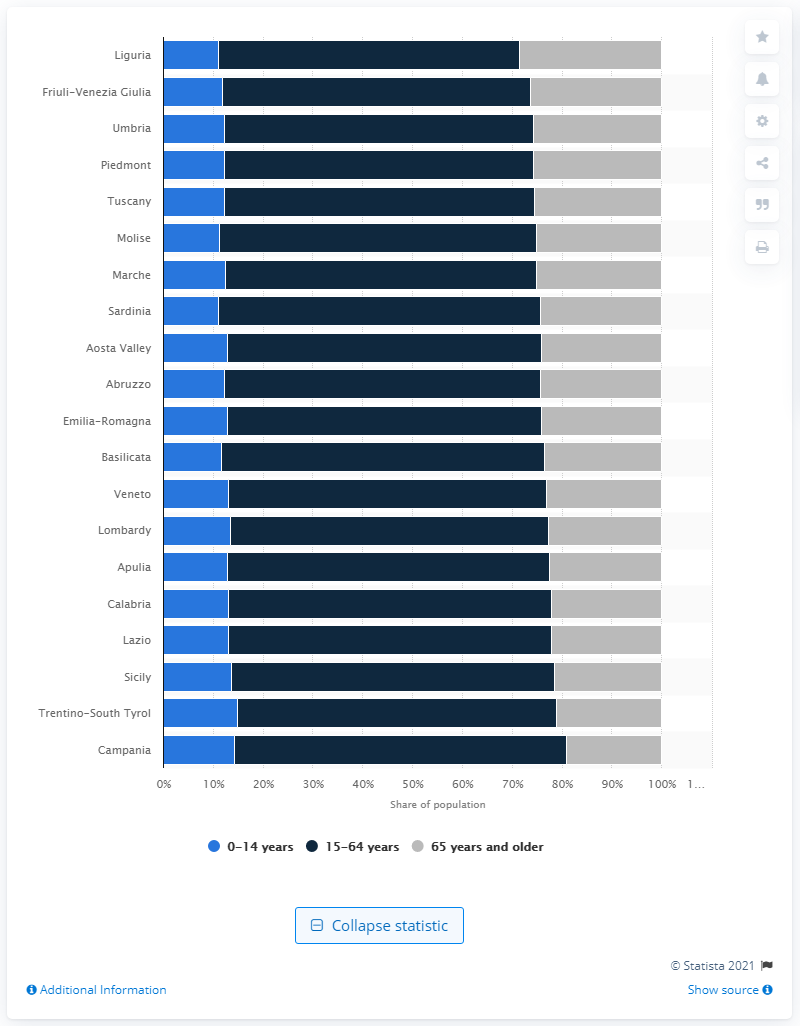Specify some key components in this picture. Liguria was the region in Italy with the largest share of population aged 65 or older in 2020. 